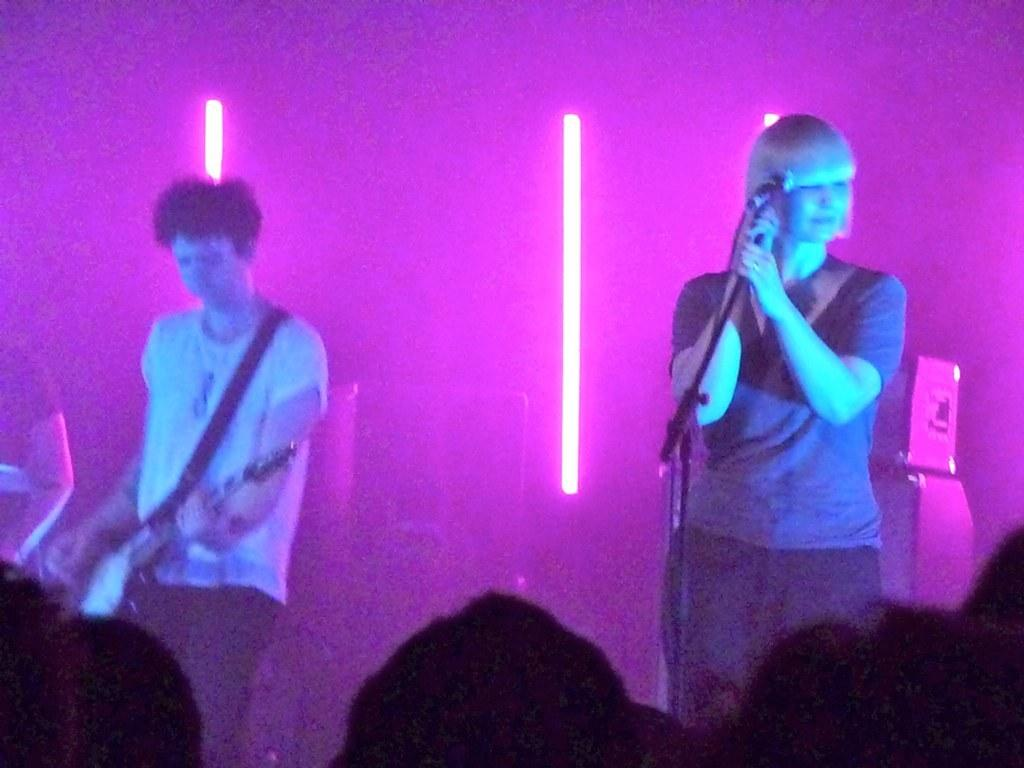What is the lady in the image holding? The lady is holding a mic in the image. What is the man in the image holding? The man is holding a guitar in the image. What can be seen in the background of the image? There are lights in the background of the image. Can you describe the people at the bottom side of the image? There are people at the bottom side of the image, but their specific actions or features are not mentioned in the provided facts. What type of box is being used by the government in the image? There is no mention of a box or the government in the image; it features a lady holding a mic and a man holding a guitar, with lights in the background and people at the bottom side. 